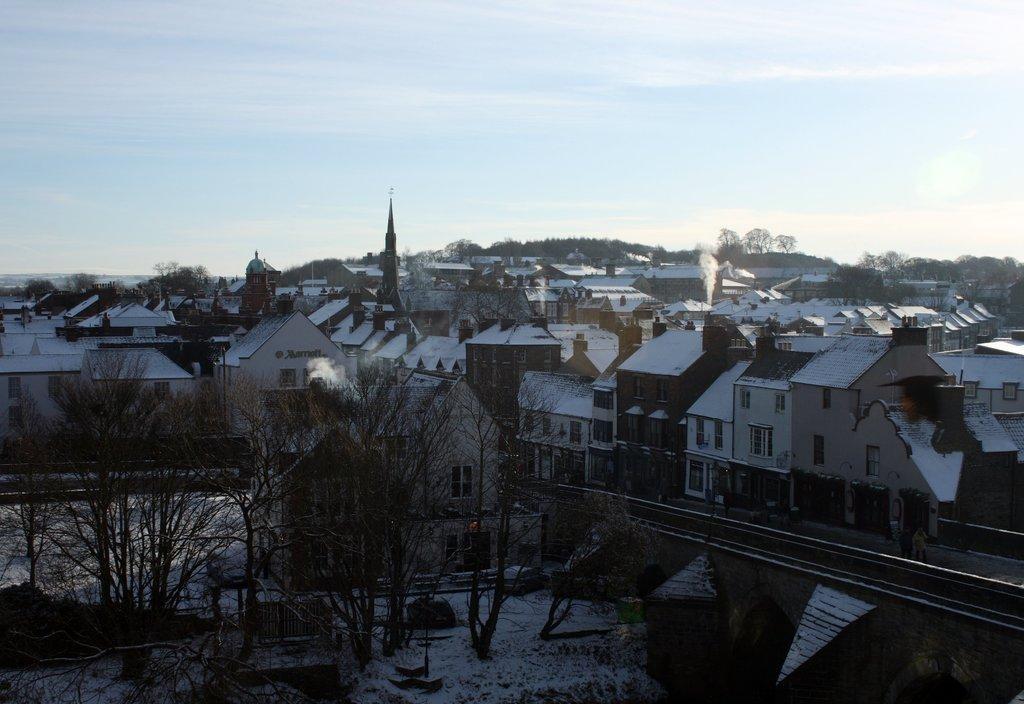In one or two sentences, can you explain what this image depicts? In this image I can see few trees, background I can see few buildings in white, brown and cream color and the sky is in white and blue color. 